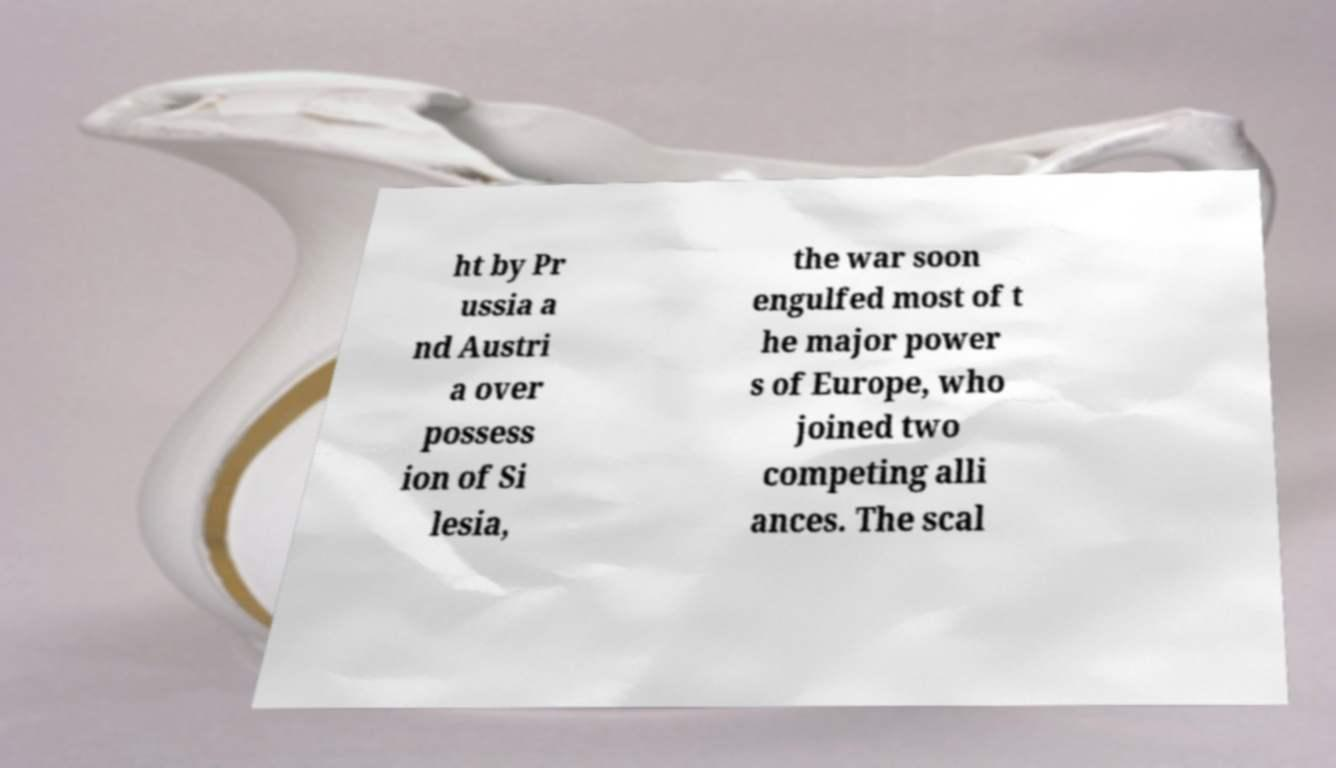Please identify and transcribe the text found in this image. ht by Pr ussia a nd Austri a over possess ion of Si lesia, the war soon engulfed most of t he major power s of Europe, who joined two competing alli ances. The scal 